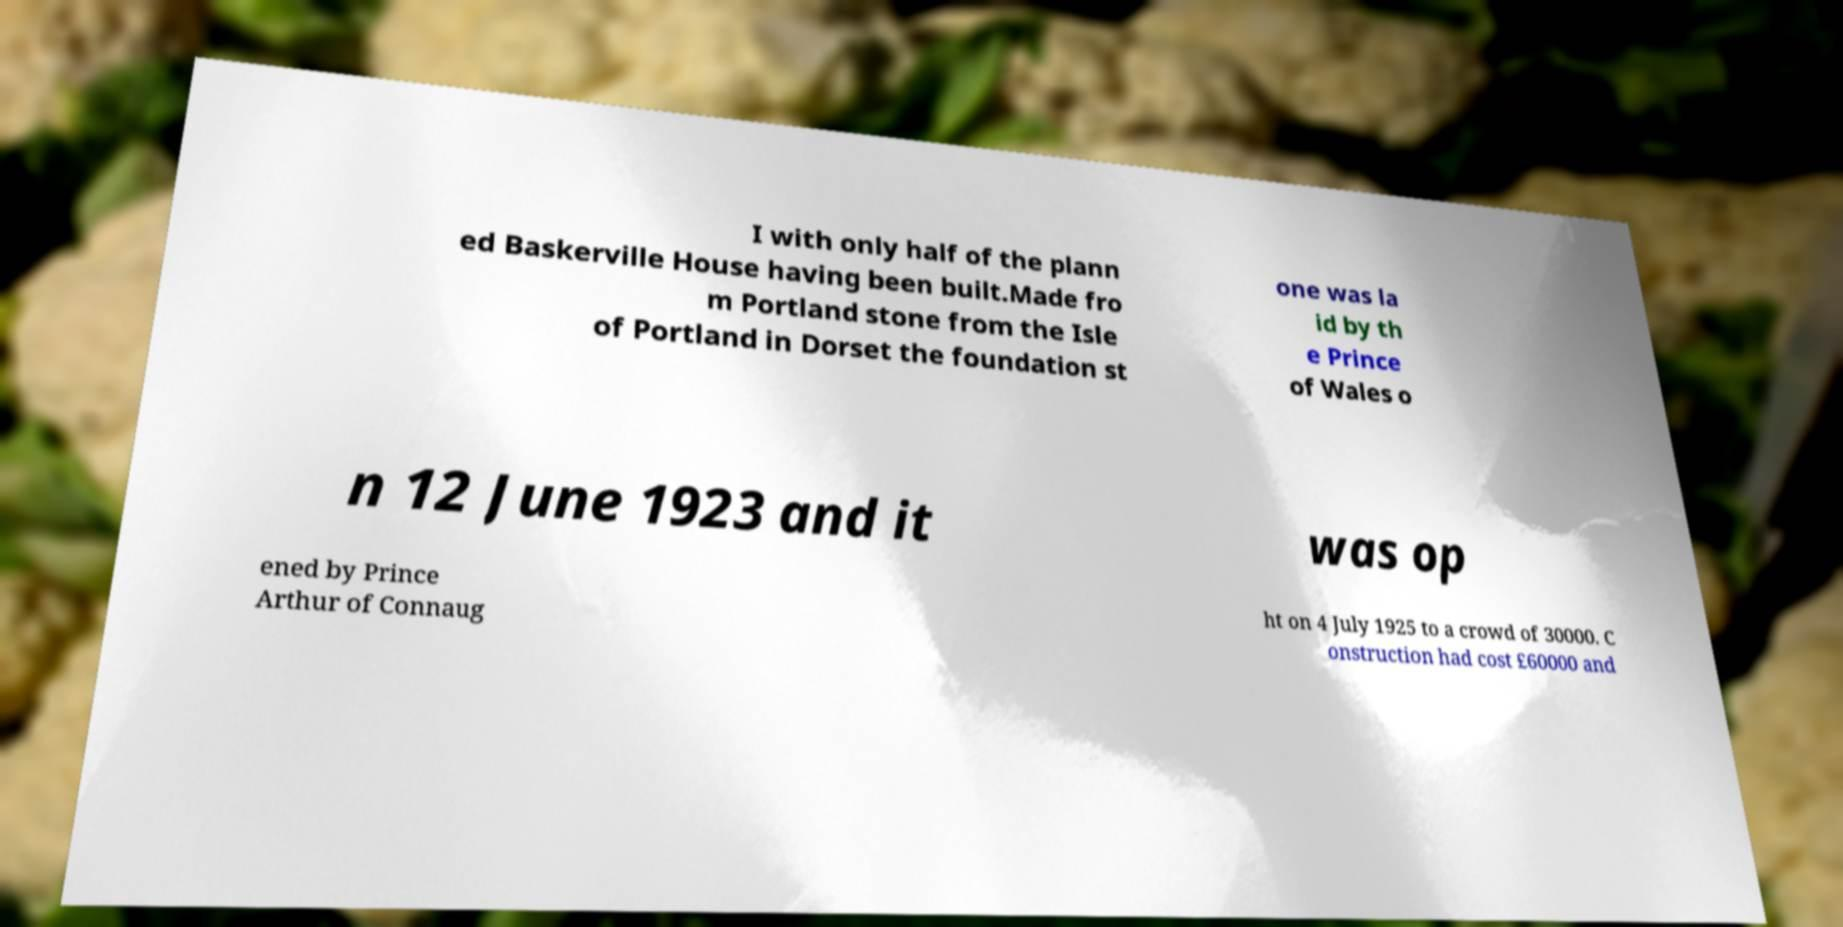Please read and relay the text visible in this image. What does it say? I with only half of the plann ed Baskerville House having been built.Made fro m Portland stone from the Isle of Portland in Dorset the foundation st one was la id by th e Prince of Wales o n 12 June 1923 and it was op ened by Prince Arthur of Connaug ht on 4 July 1925 to a crowd of 30000. C onstruction had cost £60000 and 